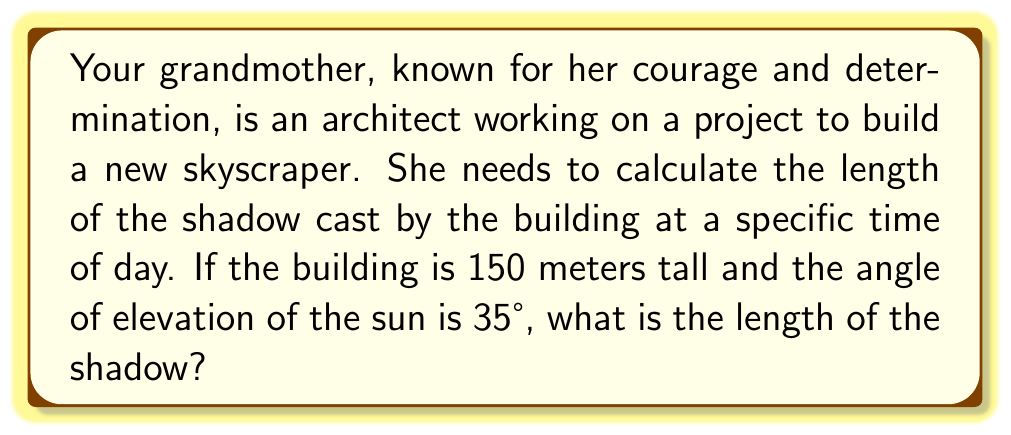What is the answer to this math problem? Let's approach this step-by-step:

1) We can visualize this problem as a right triangle, where:
   - The height of the building is the opposite side
   - The shadow length is the adjacent side
   - The sun's rays form the hypotenuse

2) We're given:
   - The height of the building: 150 meters
   - The angle of elevation of the sun: 35°

3) We need to find the adjacent side (shadow length) using the tangent function:

   $$\tan \theta = \frac{\text{opposite}}{\text{adjacent}}$$

4) In this case:

   $$\tan 35° = \frac{150}{\text{shadow length}}$$

5) To solve for the shadow length, we rearrange the equation:

   $$\text{shadow length} = \frac{150}{\tan 35°}$$

6) Using a calculator (or trigonometric tables):

   $$\text{shadow length} = \frac{150}{0.7002} \approx 214.22 \text{ meters}$$

[asy]
import geometry;

size(200);
pair A = (0,0), B = (214.22,0), C = (0,150);
draw(A--B--C--A);
draw(rightanglemark(A,B,C,20));
label("150 m", C--A, W);
label("214.22 m", A--B, S);
label("35°", A, NE);
[/asy]
Answer: 214.22 meters 